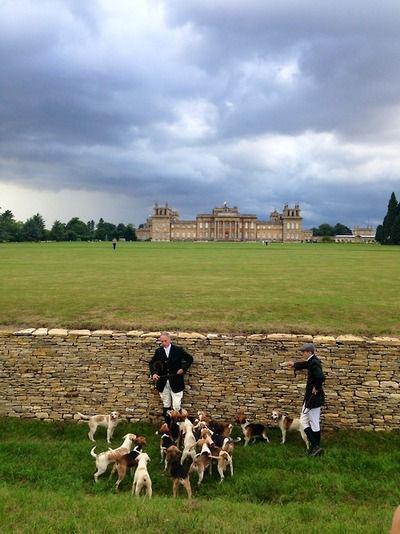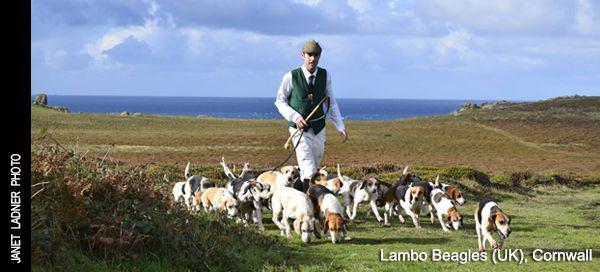The first image is the image on the left, the second image is the image on the right. Given the left and right images, does the statement "An image shows a group of at least five people walking with a pack of dogs." hold true? Answer yes or no. No. The first image is the image on the left, the second image is the image on the right. Assess this claim about the two images: "In one image, men wearing hunting clothes are with a pack of dogs adjacent to a stone wall.". Correct or not? Answer yes or no. Yes. 